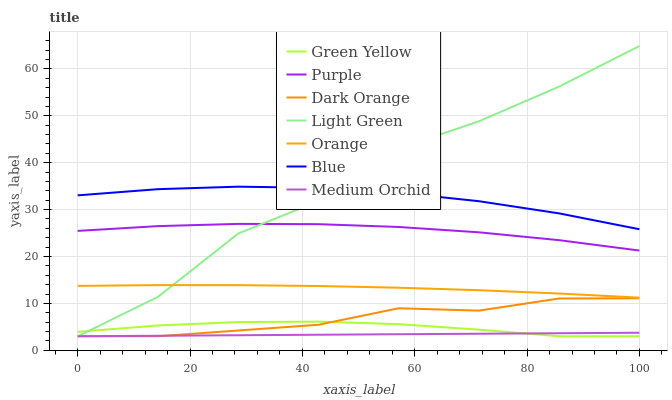Does Medium Orchid have the minimum area under the curve?
Answer yes or no. Yes. Does Light Green have the maximum area under the curve?
Answer yes or no. Yes. Does Dark Orange have the minimum area under the curve?
Answer yes or no. No. Does Dark Orange have the maximum area under the curve?
Answer yes or no. No. Is Medium Orchid the smoothest?
Answer yes or no. Yes. Is Light Green the roughest?
Answer yes or no. Yes. Is Dark Orange the smoothest?
Answer yes or no. No. Is Dark Orange the roughest?
Answer yes or no. No. Does Dark Orange have the lowest value?
Answer yes or no. Yes. Does Purple have the lowest value?
Answer yes or no. No. Does Light Green have the highest value?
Answer yes or no. Yes. Does Dark Orange have the highest value?
Answer yes or no. No. Is Dark Orange less than Orange?
Answer yes or no. Yes. Is Orange greater than Green Yellow?
Answer yes or no. Yes. Does Blue intersect Light Green?
Answer yes or no. Yes. Is Blue less than Light Green?
Answer yes or no. No. Is Blue greater than Light Green?
Answer yes or no. No. Does Dark Orange intersect Orange?
Answer yes or no. No. 